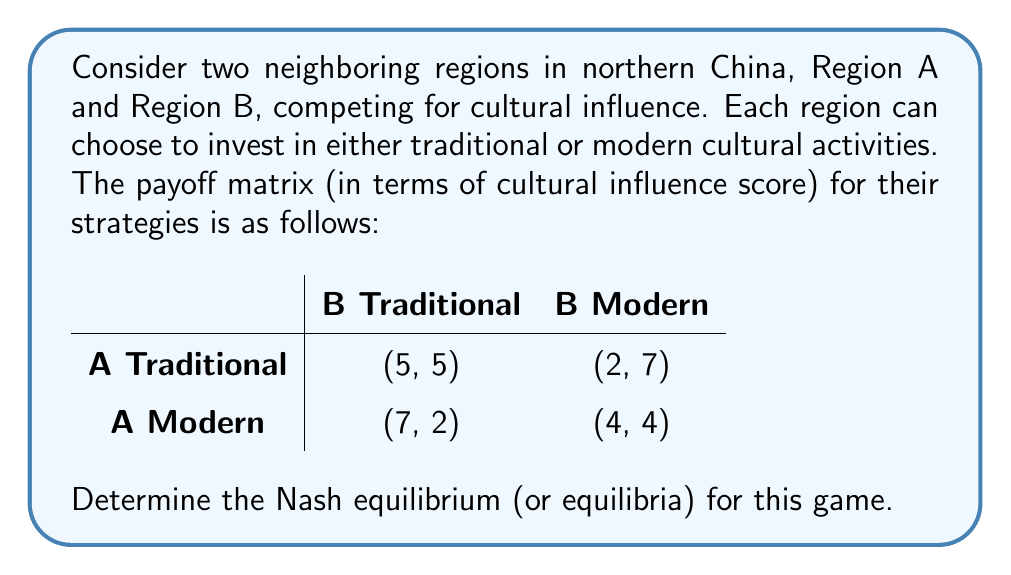Give your solution to this math problem. To find the Nash equilibrium, we need to analyze each player's best response to the other player's strategy:

1. For Region A:
   - If B chooses Traditional: A's best response is Modern (7 > 5)
   - If B chooses Modern: A's best response is Modern (4 > 2)

2. For Region B:
   - If A chooses Traditional: B's best response is Modern (7 > 5)
   - If A chooses Modern: B's best response is Modern (4 > 2)

We can see that regardless of what the other region chooses, both regions have a dominant strategy of choosing Modern cultural activities.

A Nash equilibrium occurs when each player is making the best decision for themselves, given what the other players are doing. In this case, when both regions choose Modern, neither has an incentive to unilaterally change their strategy:

- If A switches to Traditional while B stays Modern, A's payoff decreases from 4 to 2
- If B switches to Traditional while A stays Modern, B's payoff decreases from 4 to 2

Therefore, (Modern, Modern) is a Nash equilibrium. Moreover, since both players have a dominant strategy, this is the only Nash equilibrium in the game.

This result suggests that in the competition for cultural influence between neighboring regions in northern China, there might be a tendency towards modernization, potentially at the expense of traditional cultural activities.
Answer: The Nash equilibrium for this game is (Modern, Modern), with payoffs (4, 4). 